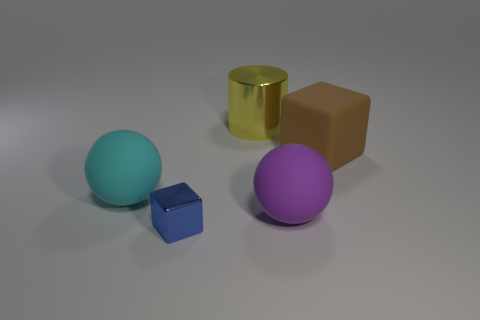Are there any objects with reflective surfaces in the image? Yes, the cylinder object has a reflective surface that is giving off a gold-like sheen. What can you tell me about the texture of the objects? The objects appear to have different textures. The spheres and the cylinder seem smooth, while the cube and the block look to have a matte finish. 